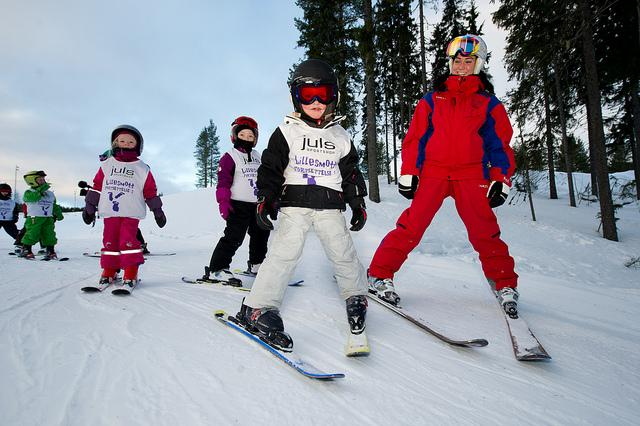Which person is the teacher? in red 